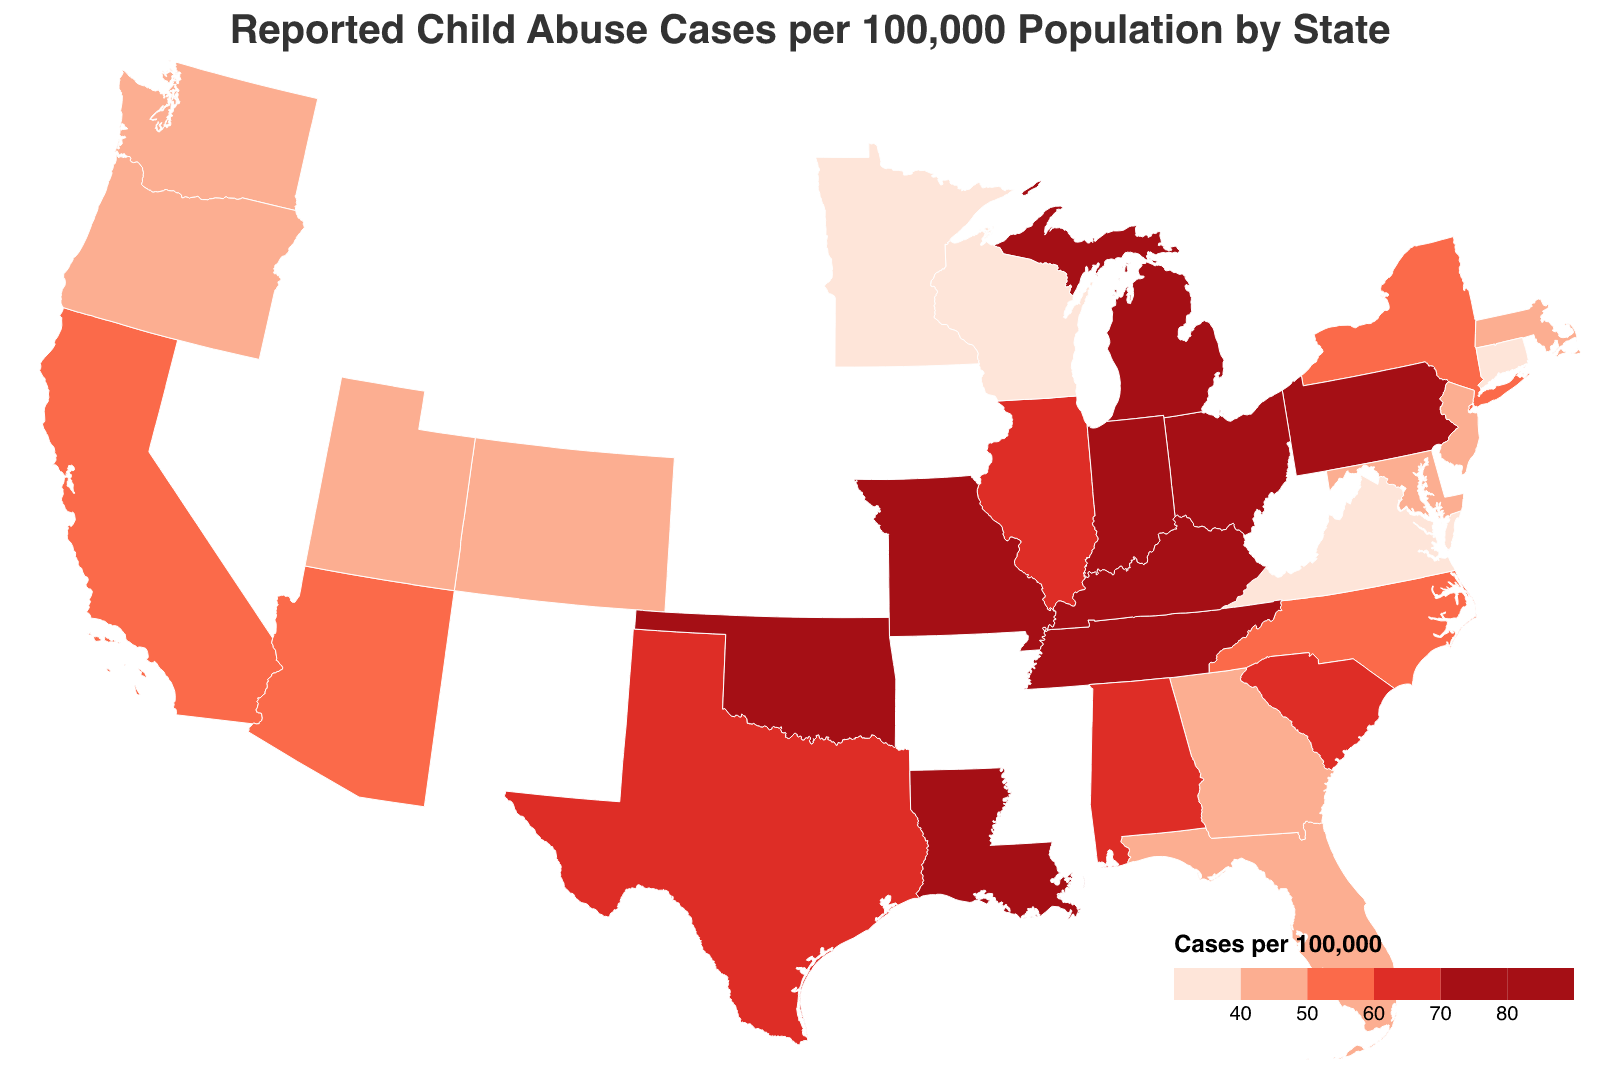Which state has the highest reported child abuse cases per 100,000 population? From the geographic plot, Ohio has the highest reported cases with a value of 87.2 per 100,000 population, as indicated by the deepest color shade.
Answer: Ohio Which state has the lowest reported child abuse cases per 100,000 population? From the geographic plot, Minnesota has the lowest reported cases with a value of 35.9 per 100,000 population, as indicated by the lightest color shade.
Answer: Minnesota What is the range of reported child abuse cases per 100,000 population across all states? The range can be calculated by subtracting the minimum value from the maximum value. From the plot, the highest value is 87.2 (Ohio) and the lowest is 35.9 (Minnesota). Thus, the range is 87.2 - 35.9.
Answer: 51.3 Which states have a reported child abuse rate per 100,000 population greater than 80? By observing the plot, the states with rates greater than 80 are Ohio (87.2), Kentucky (81.4), and Oklahoma (82.8).
Answer: Ohio, Kentucky, Oklahoma How many states have a reported child abuse rate per 100,000 population below 40? From the plot, the states with rates below 40 are Virginia (38.7), Wisconsin (39.6), Minnesota (35.9), and Connecticut (36.4). Hence, there are 4 states.
Answer: 4 Compare the reported child abuse cases per 100,000 population between California and Texas. Which state has a higher rate and by how much? From the plot, California has 52.3 reported cases, and Texas has 61.8. Texas has a higher rate. The difference is 61.8 - 52.3.
Answer: Texas by 9.5 Identify the geographic patterns of the reported child abuse cases. Are there more hotspots in any specific region of the US? By observing the color intensity across the map, the Midwest (e.g., Ohio, Kentucky) and parts of the South (e.g., Tennessee, Louisiana) show deeper shades indicating higher numbers of reported child abuse cases.
Answer: Midwest and South What is the average reported child abuse rate per 100,000 population for the states listed? To find the average, sum up all reported cases and divide by the number of states. The sum is 52.3 + 61.8 + 45.6 + 56.7 + 72.4 + 68.9 + 87.2 + 49.1 + 58.3 + 79.5 + 41.2 + 38.7 + 44.5 + 59.8 + 40.1 + 76.3 + 83.6 + 74.9 + 43.8 + 39.6 + 47.2 + 35.9 + 69.5 + 65.7 + 80.1 + 81.4 + 42.3 + 82.8 + 36.4 + 40.7 = 1651.2. Dividing by the number of states (30), the average is 1651.2 / 30.
Answer: 55.04 What colors are used on the geographic plot to represent the different ranges of reported child abuse cases per 100,000 population? The plot uses a color gradient from light (#fee5d9) to dark red (#a50f15) with different shades representing the thresholds 40, 50, 60, 70, and 80.
Answer: Light pink to dark red 